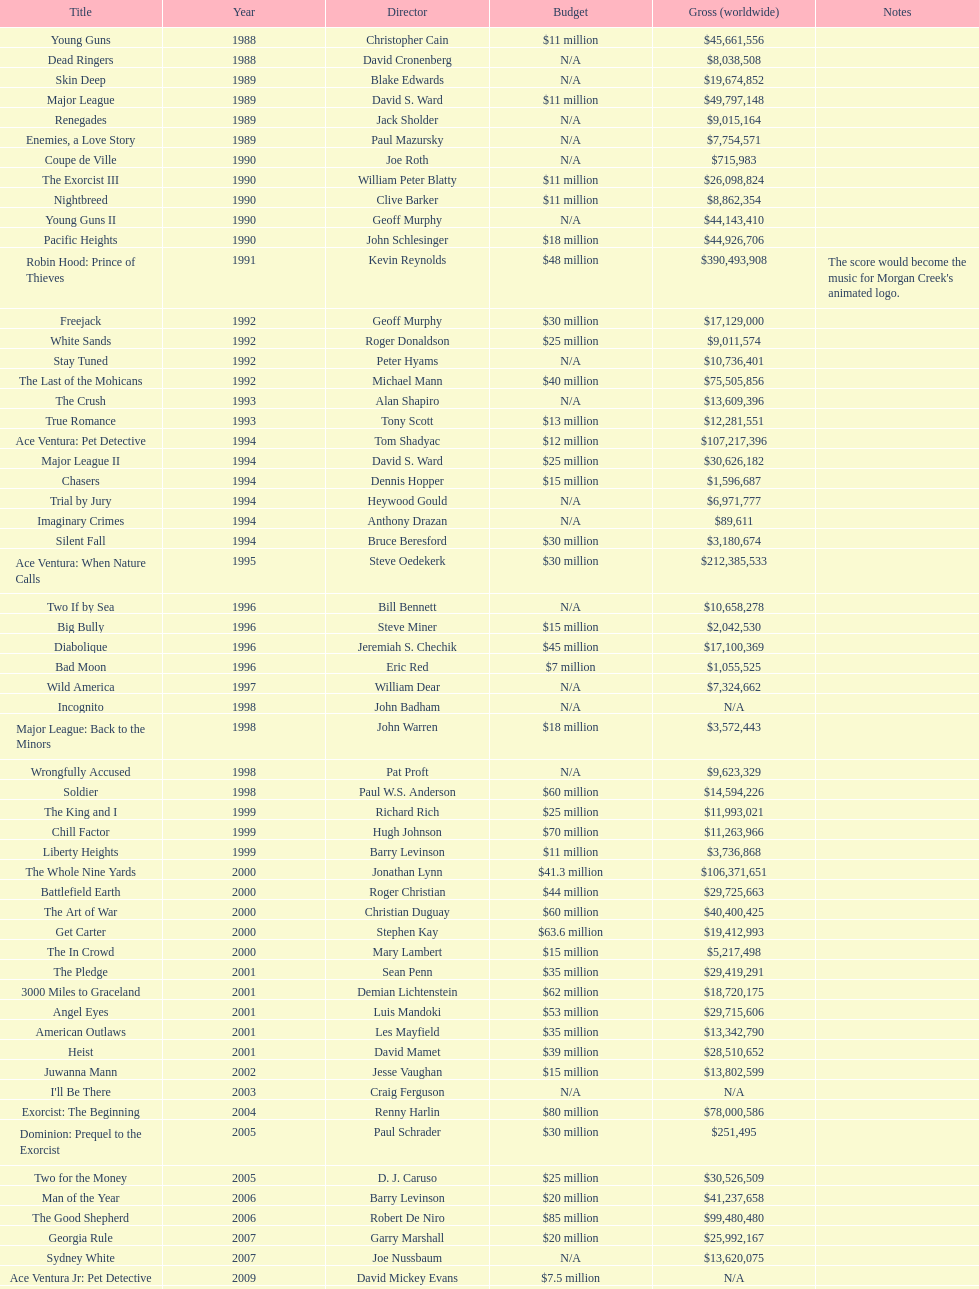Which film produced by morgan creek had the highest worldwide gross? Robin Hood: Prince of Thieves. 